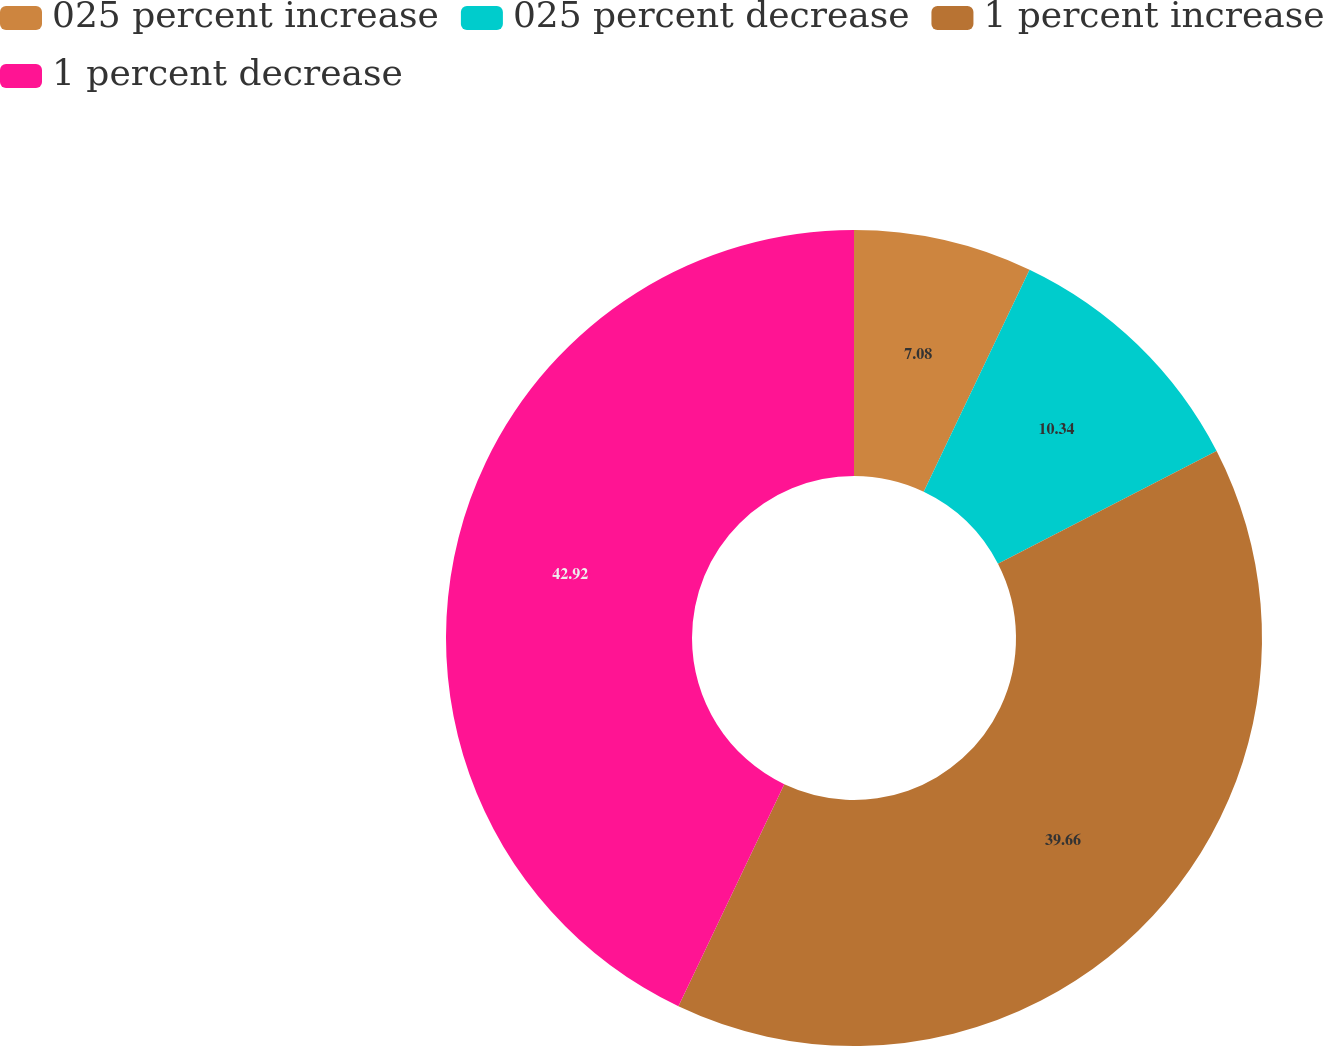Convert chart to OTSL. <chart><loc_0><loc_0><loc_500><loc_500><pie_chart><fcel>025 percent increase<fcel>025 percent decrease<fcel>1 percent increase<fcel>1 percent decrease<nl><fcel>7.08%<fcel>10.34%<fcel>39.66%<fcel>42.92%<nl></chart> 